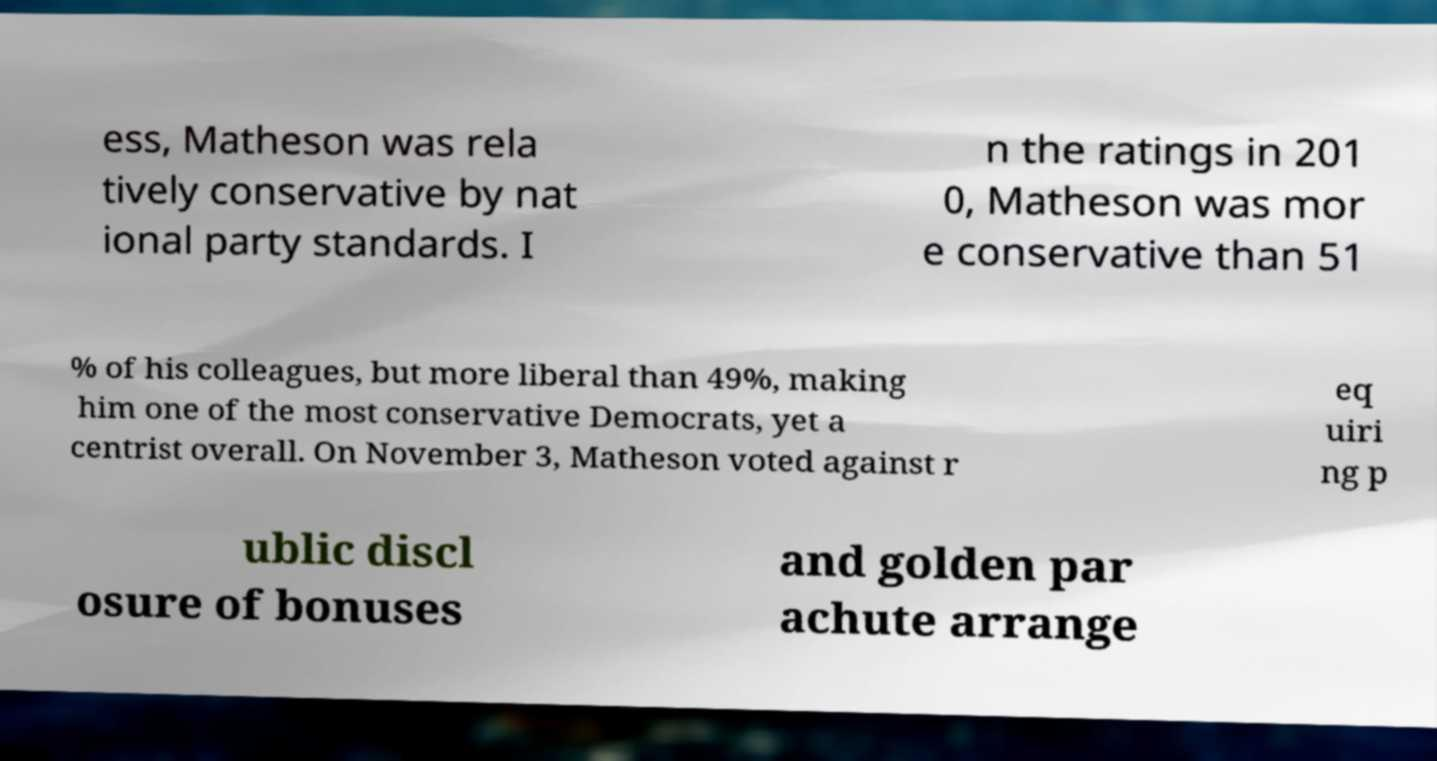For documentation purposes, I need the text within this image transcribed. Could you provide that? ess, Matheson was rela tively conservative by nat ional party standards. I n the ratings in 201 0, Matheson was mor e conservative than 51 % of his colleagues, but more liberal than 49%, making him one of the most conservative Democrats, yet a centrist overall. On November 3, Matheson voted against r eq uiri ng p ublic discl osure of bonuses and golden par achute arrange 